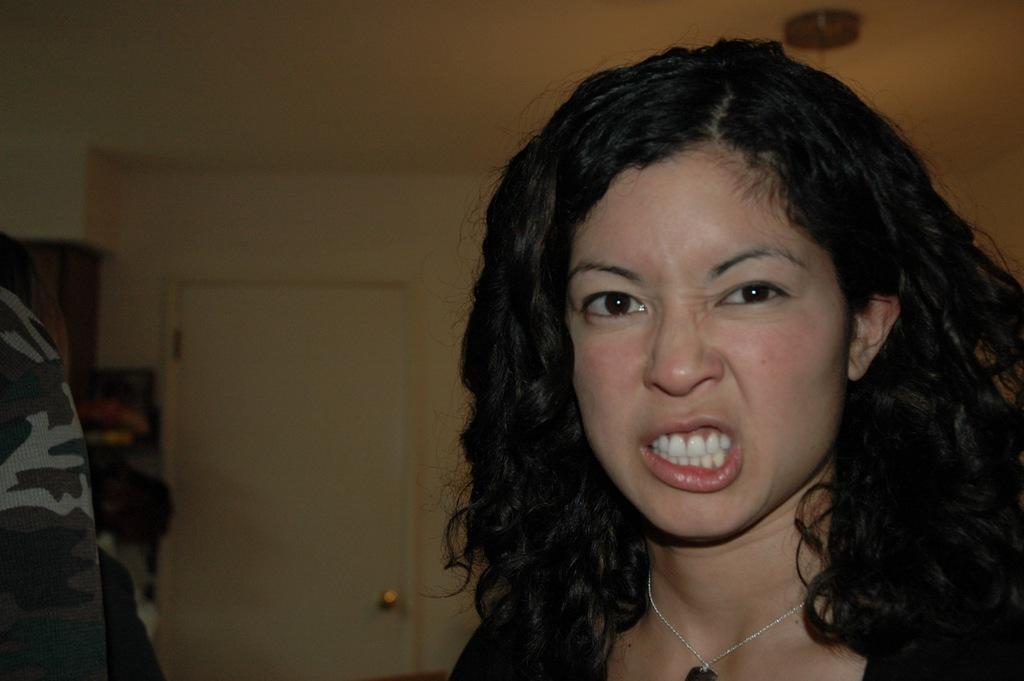Please provide a concise description of this image. In this picture, we can see a lady, and we can see some objects on the left side of the picture, like cloth, and we can see the wall with door, roof with some object attached to it. 